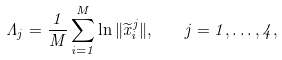<formula> <loc_0><loc_0><loc_500><loc_500>\Lambda _ { j } = \frac { 1 } { M } \sum _ { i = 1 } ^ { M } \ln \| \widetilde { x } _ { i } ^ { j } \| , \quad j = 1 , \dots , 4 ,</formula> 